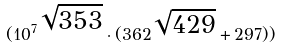Convert formula to latex. <formula><loc_0><loc_0><loc_500><loc_500>( { 1 0 ^ { 7 } } ^ { \sqrt { 3 5 3 } } \cdot ( 3 6 2 ^ { \sqrt { 4 2 9 } } + 2 9 7 ) )</formula> 